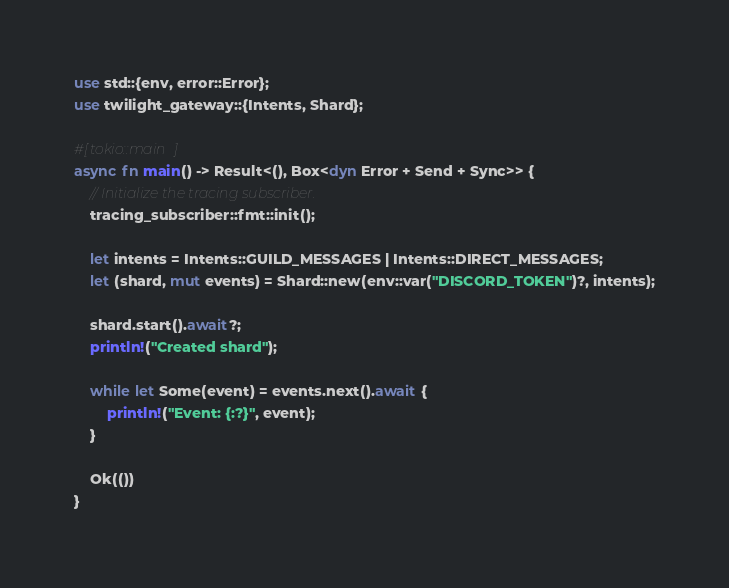<code> <loc_0><loc_0><loc_500><loc_500><_Rust_>use std::{env, error::Error};
use twilight_gateway::{Intents, Shard};

#[tokio::main]
async fn main() -> Result<(), Box<dyn Error + Send + Sync>> {
    // Initialize the tracing subscriber.
    tracing_subscriber::fmt::init();

    let intents = Intents::GUILD_MESSAGES | Intents::DIRECT_MESSAGES;
    let (shard, mut events) = Shard::new(env::var("DISCORD_TOKEN")?, intents);

    shard.start().await?;
    println!("Created shard");

    while let Some(event) = events.next().await {
        println!("Event: {:?}", event);
    }

    Ok(())
}
</code> 